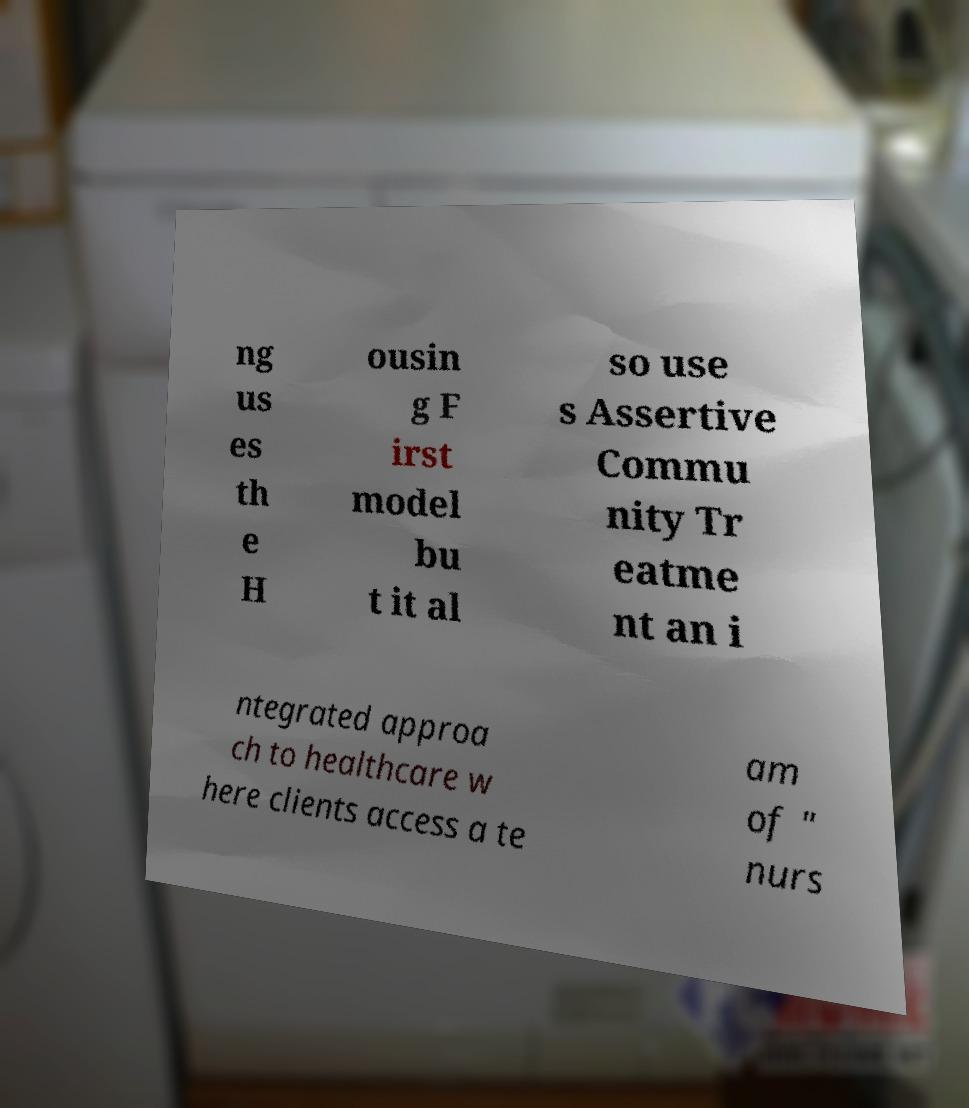Could you extract and type out the text from this image? ng us es th e H ousin g F irst model bu t it al so use s Assertive Commu nity Tr eatme nt an i ntegrated approa ch to healthcare w here clients access a te am of " nurs 